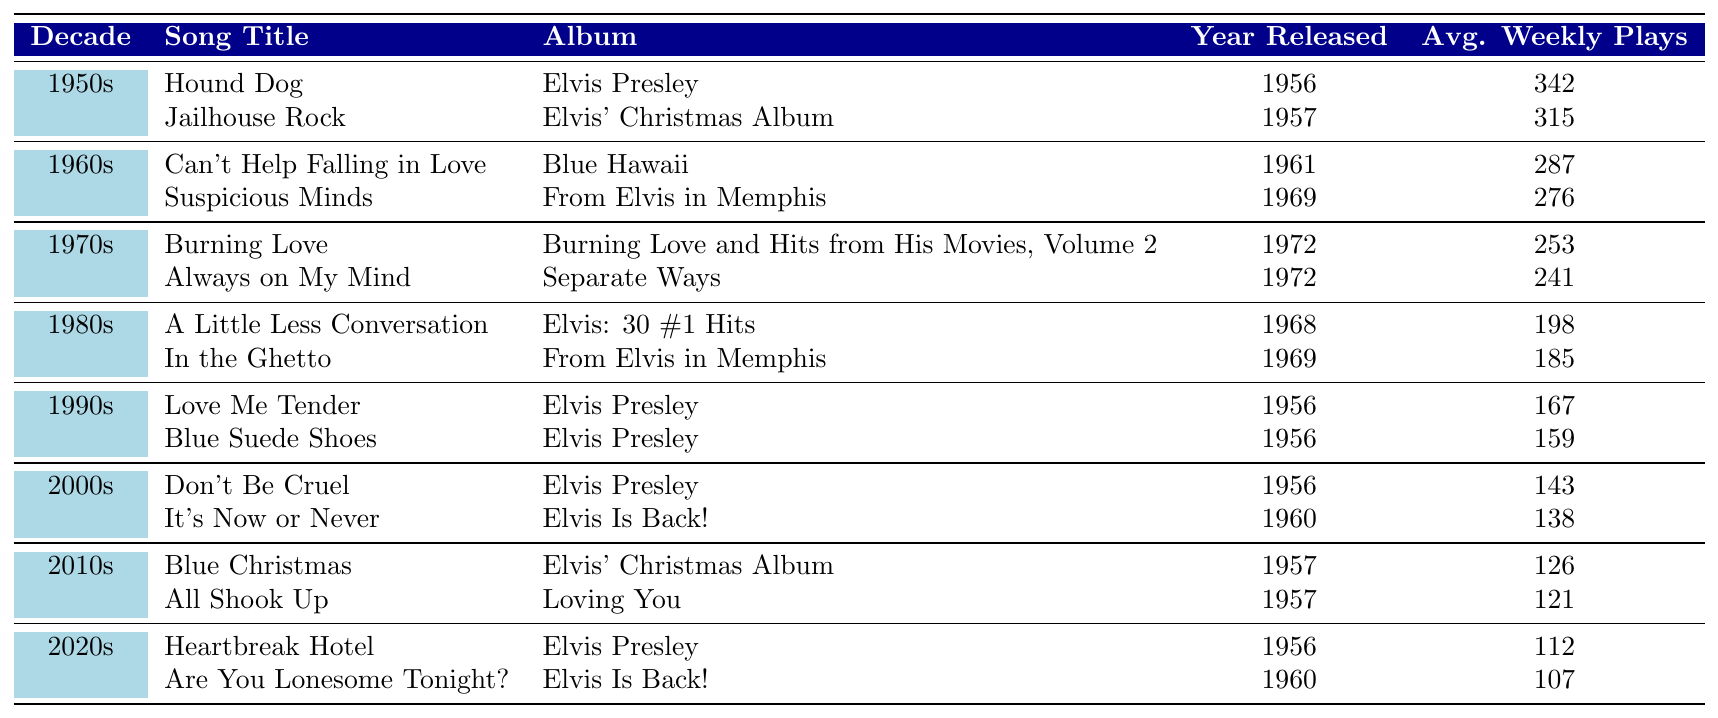What is the song with the highest average weekly plays from the 1950s? The 1950s column shows that "Hound Dog" has the highest average weekly plays at 342.
Answer: Hound Dog How many Elvis songs were released in the 1970s? There are 2 songs listed in the 1970s: "Burning Love" and "Always on My Mind."
Answer: 2 Which song has the lowest average weekly plays in the 2000s? In the 2000s, "It's Now or Never" has the lowest average weekly plays at 138.
Answer: It's Now or Never Is "Suspicious Minds" more popular than "Can't Help Falling in Love"? "Suspicious Minds" has an average of 276 plays, while "Can't Help Falling in Love" has 287 plays, making it less popular.
Answer: No What decade had the song "Blue Christmas" and what was its average weekly plays? "Blue Christmas" is from the 2010s and has an average of 126 weekly plays.
Answer: 2010s, 126 What is the average weekly plays of Elvis songs from the 1990s? The total plays for the two songs in the 1990s are 167 + 159 = 326. There are 2 songs, so the average is 326 / 2 = 163.
Answer: 163 How many decades are represented in the table? The table includes songs from 7 different decades: the 1950s, 1960s, 1970s, 1980s, 1990s, 2000s, 2010s, and 2020s.
Answer: 7 Which song from the 2020s has the highest average weekly plays? In the 2020s, "Heartbreak Hotel" has the higher average with 112 compared to "Are You Lonesome Tonight?" which has 107.
Answer: Heartbreak Hotel What is the difference in average weekly plays between the most-played song of the 1950s and the most-played song of the 1980s? The difference is 342 (Hound Dog from the 1950s) - 198 (A Little Less Conversation from the 1980s) = 144.
Answer: 144 Which song appears in both the 1980s and was originally released in the 1960s? "A Little Less Conversation" appears in the 1980s but was originally released in 1968.
Answer: A Little Less Conversation 